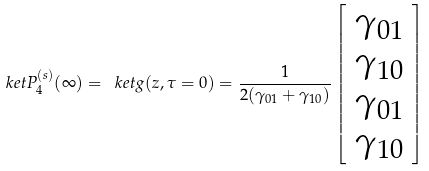<formula> <loc_0><loc_0><loc_500><loc_500>\ k e t { P _ { 4 } ^ { ( s ) } ( \infty ) } = \ k e t { g ( z , \tau = 0 ) } = \frac { 1 } { 2 ( \gamma _ { 0 1 } + \gamma _ { 1 0 } ) } \left [ \begin{array} { l } \gamma _ { 0 1 } \\ \gamma _ { 1 0 } \\ \gamma _ { 0 1 } \\ \gamma _ { 1 0 } \end{array} \right ]</formula> 